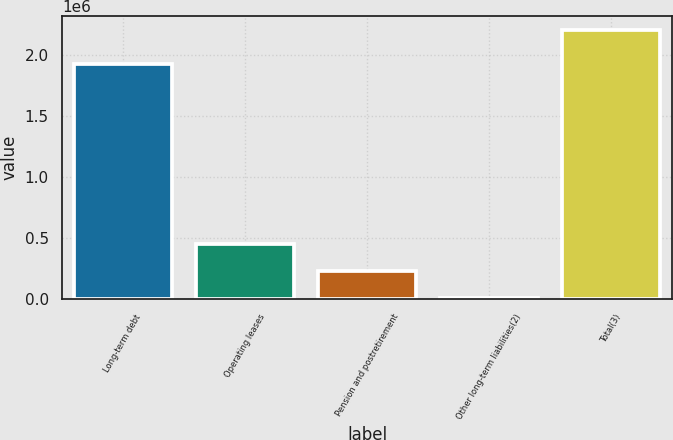Convert chart to OTSL. <chart><loc_0><loc_0><loc_500><loc_500><bar_chart><fcel>Long-term debt<fcel>Operating leases<fcel>Pension and postretirement<fcel>Other long-term liabilities(2)<fcel>Total(3)<nl><fcel>1.9249e+06<fcel>450967<fcel>231178<fcel>11390<fcel>2.20928e+06<nl></chart> 